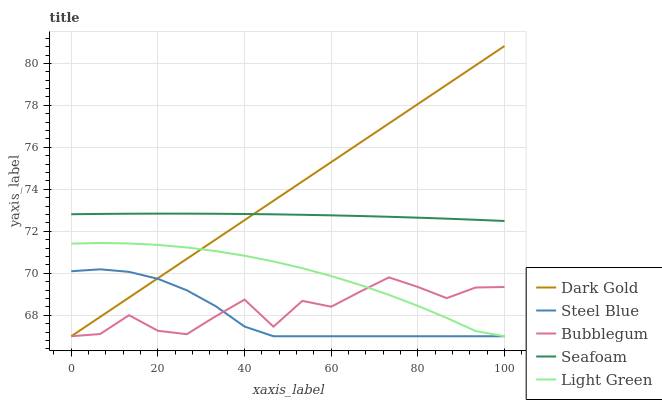Does Steel Blue have the minimum area under the curve?
Answer yes or no. Yes. Does Dark Gold have the maximum area under the curve?
Answer yes or no. Yes. Does Seafoam have the minimum area under the curve?
Answer yes or no. No. Does Seafoam have the maximum area under the curve?
Answer yes or no. No. Is Dark Gold the smoothest?
Answer yes or no. Yes. Is Bubblegum the roughest?
Answer yes or no. Yes. Is Seafoam the smoothest?
Answer yes or no. No. Is Seafoam the roughest?
Answer yes or no. No. Does Seafoam have the lowest value?
Answer yes or no. No. Does Seafoam have the highest value?
Answer yes or no. No. Is Steel Blue less than Seafoam?
Answer yes or no. Yes. Is Seafoam greater than Steel Blue?
Answer yes or no. Yes. Does Steel Blue intersect Seafoam?
Answer yes or no. No. 